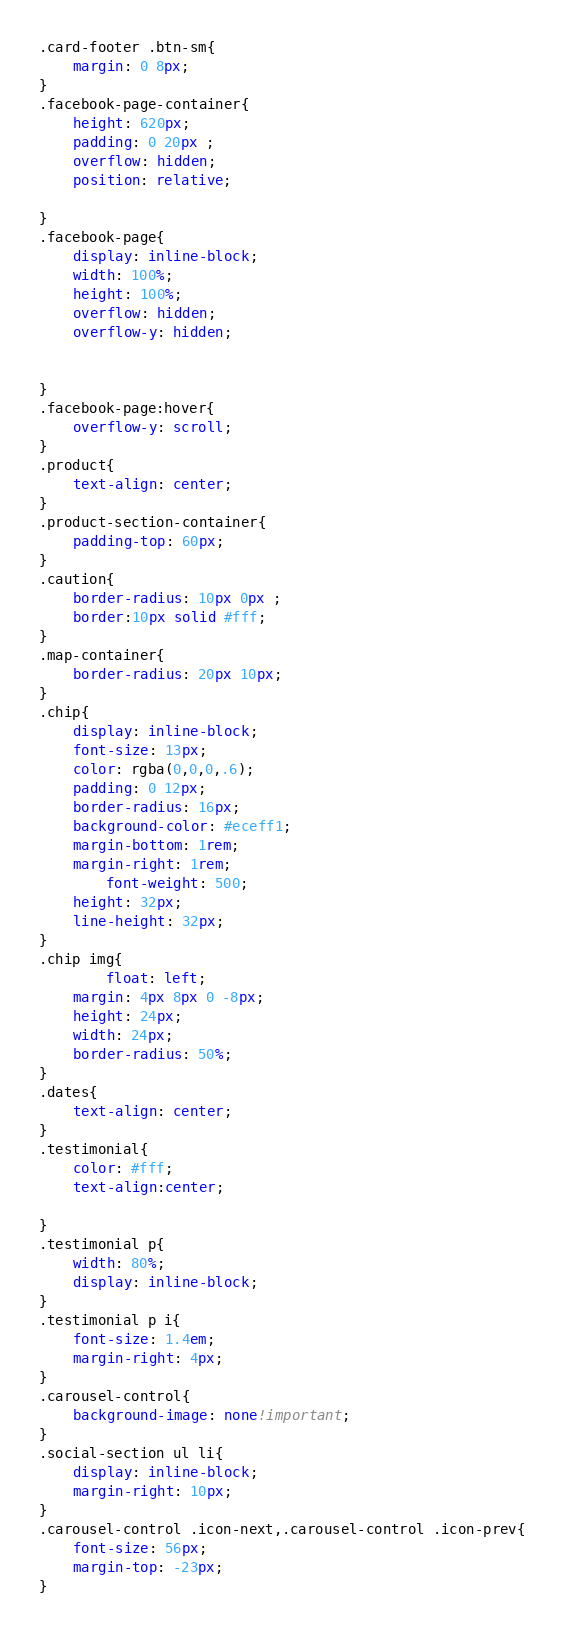Convert code to text. <code><loc_0><loc_0><loc_500><loc_500><_CSS_>.card-footer .btn-sm{
    margin: 0 8px;
}
.facebook-page-container{
    height: 620px;
    padding: 0 20px ;
    overflow: hidden;
    position: relative;

}
.facebook-page{
    display: inline-block;
    width: 100%;
    height: 100%;
    overflow: hidden;
    overflow-y: hidden;


}
.facebook-page:hover{
    overflow-y: scroll;
}
.product{
    text-align: center;
}
.product-section-container{
    padding-top: 60px;
}
.caution{
    border-radius: 10px 0px ;
    border:10px solid #fff;
}
.map-container{
    border-radius: 20px 10px;
}
.chip{
    display: inline-block;
    font-size: 13px;
    color: rgba(0,0,0,.6);
    padding: 0 12px;
    border-radius: 16px;
    background-color: #eceff1;
    margin-bottom: 1rem;
    margin-right: 1rem;
        font-weight: 500;
    height: 32px;
    line-height: 32px;
}
.chip img{
        float: left;
    margin: 4px 8px 0 -8px;
    height: 24px;
    width: 24px;
    border-radius: 50%;
}
.dates{
    text-align: center;
}
.testimonial{
    color: #fff;
    text-align:center;

}
.testimonial p{
    width: 80%;
    display: inline-block;
}
.testimonial p i{
    font-size: 1.4em;
    margin-right: 4px;
}
.carousel-control{
    background-image: none!important;
}
.social-section ul li{
    display: inline-block;
    margin-right: 10px;
}
.carousel-control .icon-next,.carousel-control .icon-prev{
    font-size: 56px;
    margin-top: -23px;
}</code> 